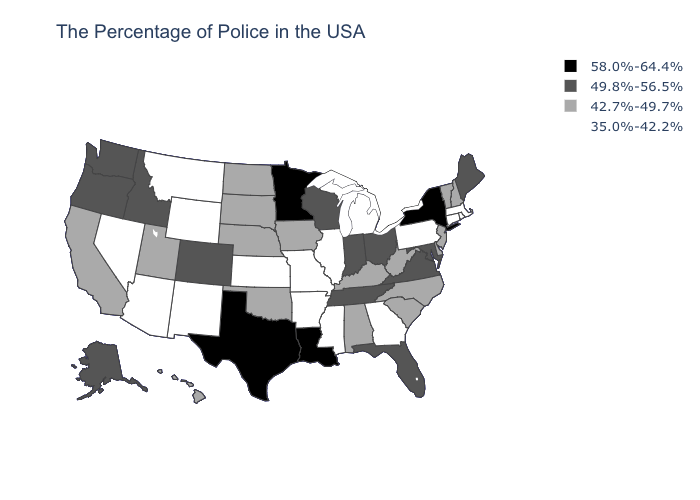Does the map have missing data?
Concise answer only. No. What is the value of Florida?
Be succinct. 49.8%-56.5%. Does Rhode Island have the lowest value in the USA?
Give a very brief answer. Yes. What is the lowest value in states that border California?
Give a very brief answer. 35.0%-42.2%. What is the value of Maryland?
Quick response, please. 49.8%-56.5%. Which states have the lowest value in the South?
Quick response, please. Georgia, Mississippi, Arkansas. What is the value of Missouri?
Write a very short answer. 35.0%-42.2%. Among the states that border New Hampshire , which have the lowest value?
Keep it brief. Massachusetts. What is the value of Nebraska?
Concise answer only. 42.7%-49.7%. What is the highest value in the MidWest ?
Be succinct. 58.0%-64.4%. Which states have the highest value in the USA?
Concise answer only. New York, Louisiana, Minnesota, Texas. Does Wisconsin have a lower value than Texas?
Quick response, please. Yes. Which states have the lowest value in the USA?
Write a very short answer. Massachusetts, Rhode Island, Connecticut, Pennsylvania, Georgia, Michigan, Illinois, Mississippi, Missouri, Arkansas, Kansas, Wyoming, New Mexico, Montana, Arizona, Nevada. What is the value of Delaware?
Give a very brief answer. 42.7%-49.7%. 